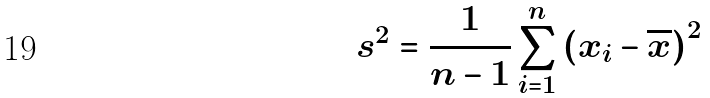Convert formula to latex. <formula><loc_0><loc_0><loc_500><loc_500>s ^ { 2 } = { \frac { 1 } { n - 1 } } \sum _ { i = 1 } ^ { n } \left ( x _ { i } - { \overline { x } } \right ) ^ { 2 }</formula> 